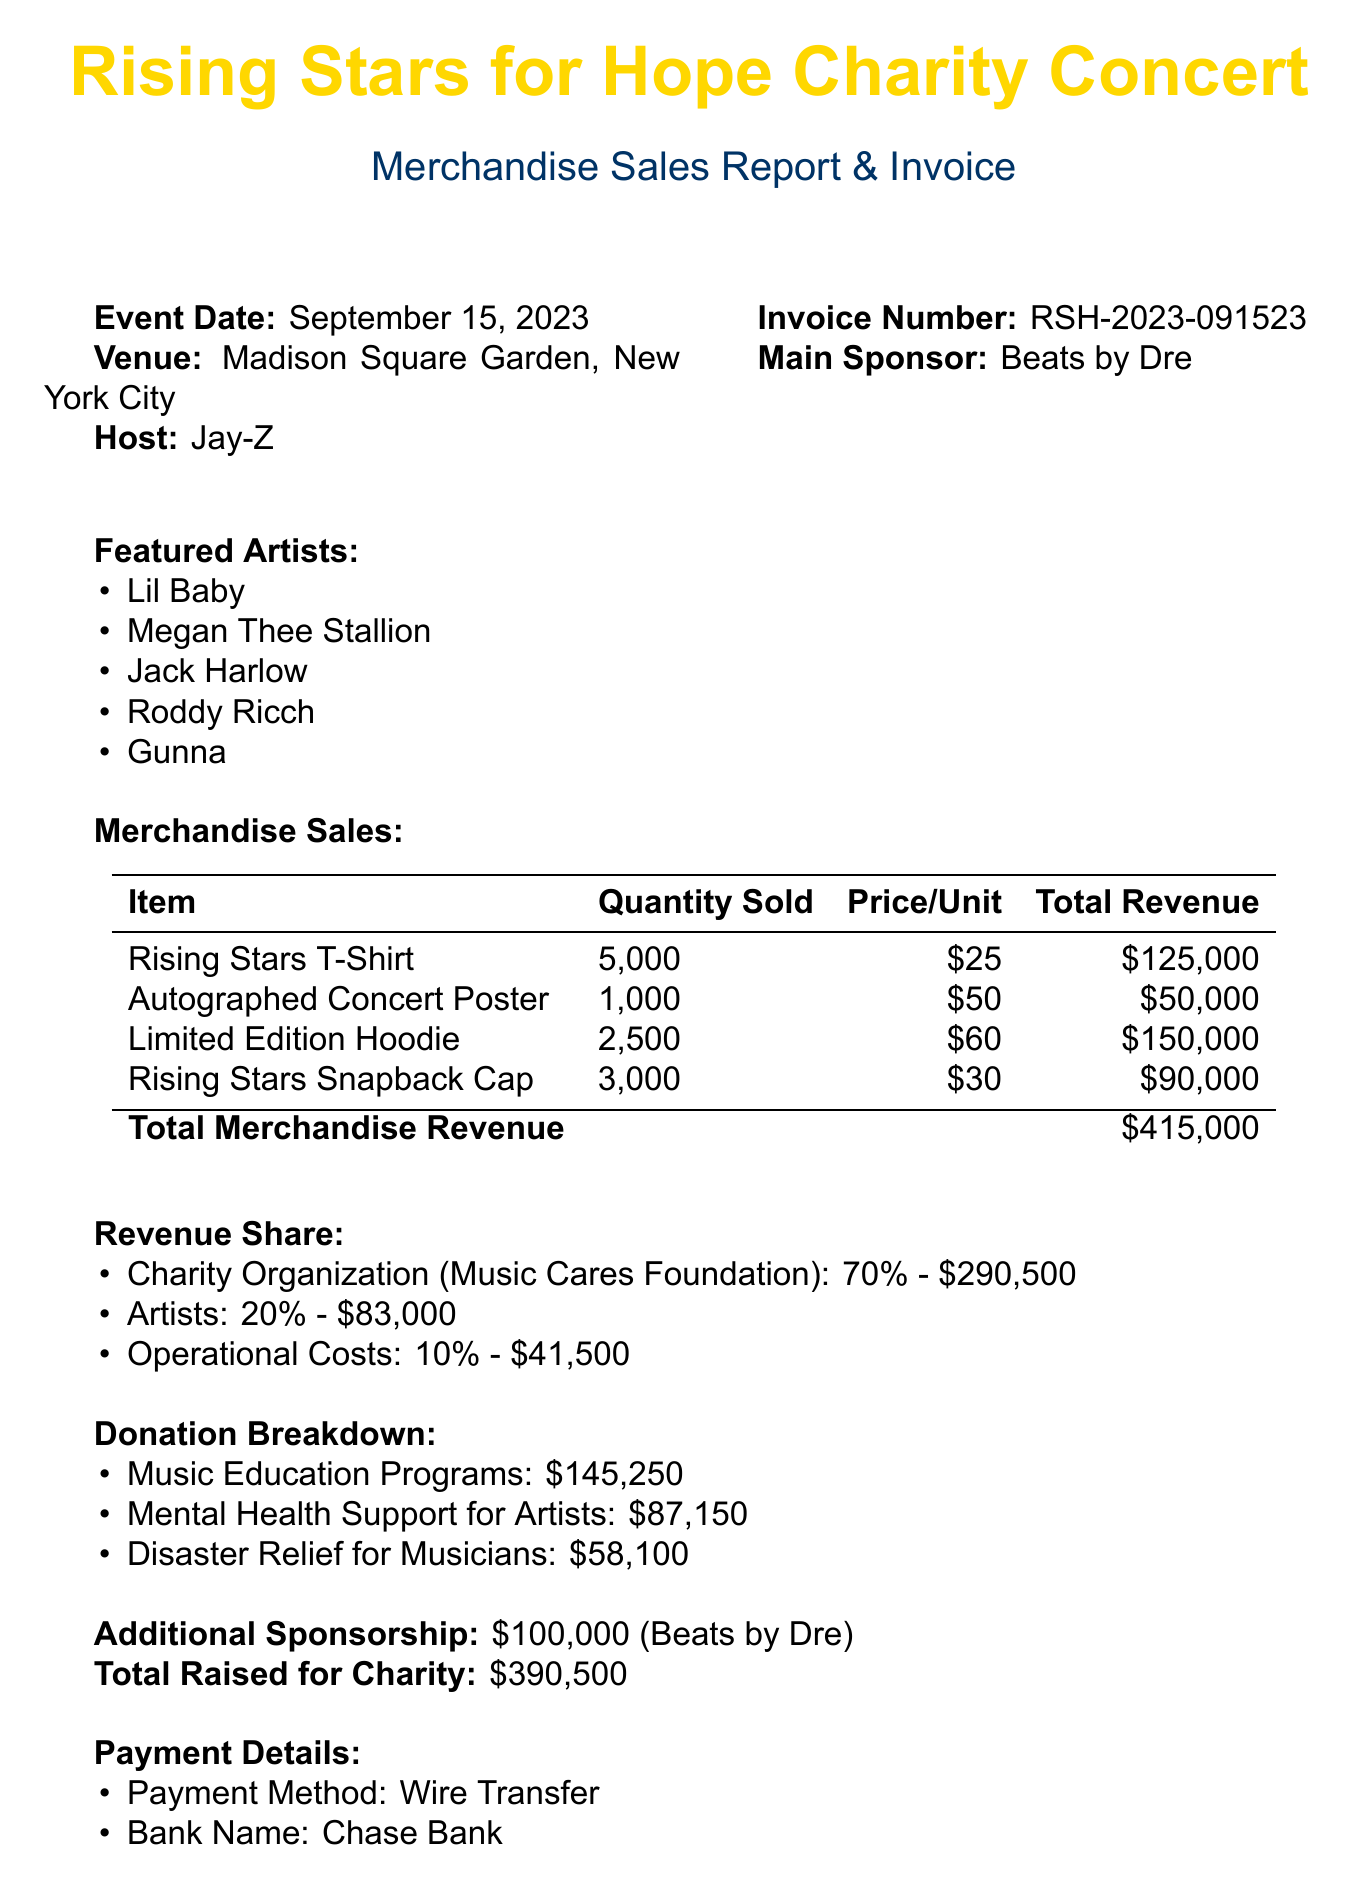What is the event name? The event name is specified at the top of the document.
Answer: Rising Stars for Hope Charity Concert What is the total merchandise revenue? The total merchandise revenue is listed in the merchandise sales section.
Answer: $415,000 Who is the main sponsor of the event? The main sponsor is explicitly mentioned in the invoice details.
Answer: Beats by Dre How much percentage of the revenue goes to the charity organization? The charity percentage is outlined in the revenue share details.
Answer: 70% What is the total amount donated to music education programs? The donation breakdown specifies the amount for music education programs.
Answer: $145,250 What are the total operational costs? The operational costs amount is stated in the revenue share section.
Answer: $41,500 How many autographed concert posters were sold? The quantity sold for each merchandise item is provided in the merchandise sales section.
Answer: 1,000 What payment method is used? The payment details section describes the payment method accepted.
Answer: Wire Transfer What is the invoice number? The invoice number is listed in the details section of the document.
Answer: RSH-2023-091523 